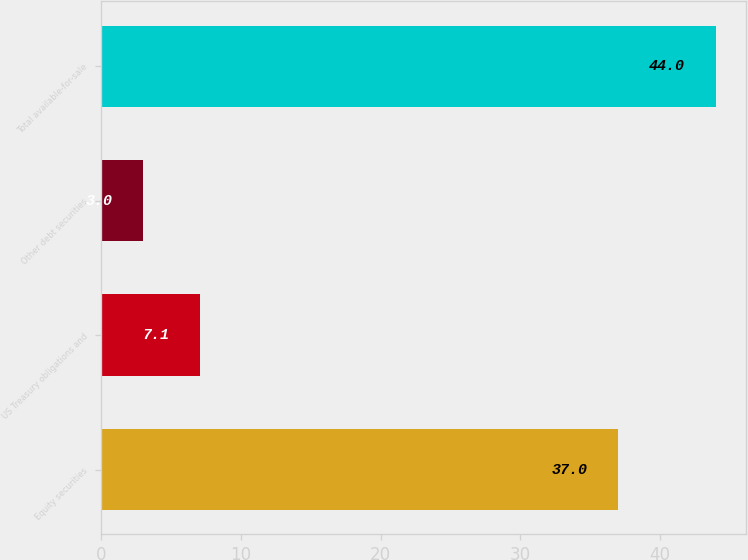Convert chart to OTSL. <chart><loc_0><loc_0><loc_500><loc_500><bar_chart><fcel>Equity securities<fcel>US Treasury obligations and<fcel>Other debt securities<fcel>Total available-for-sale<nl><fcel>37<fcel>7.1<fcel>3<fcel>44<nl></chart> 